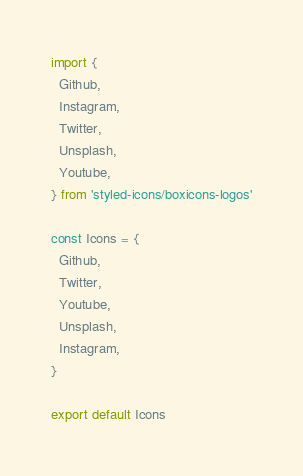<code> <loc_0><loc_0><loc_500><loc_500><_JavaScript_>import {
  Github,
  Instagram,
  Twitter,
  Unsplash,
  Youtube,
} from 'styled-icons/boxicons-logos'

const Icons = {
  Github,
  Twitter,
  Youtube,
  Unsplash,
  Instagram,
}

export default Icons
</code> 